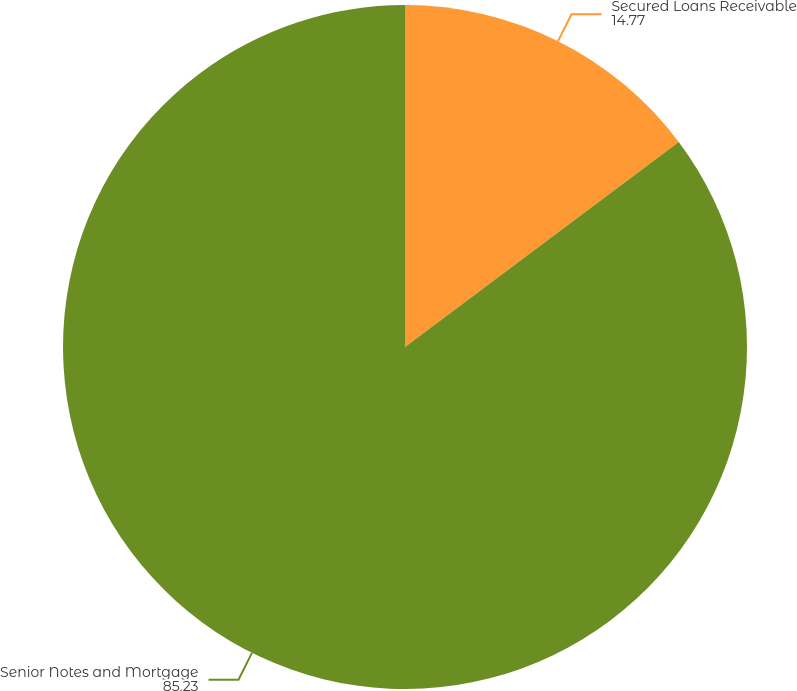Convert chart to OTSL. <chart><loc_0><loc_0><loc_500><loc_500><pie_chart><fcel>Secured Loans Receivable<fcel>Senior Notes and Mortgage<nl><fcel>14.77%<fcel>85.23%<nl></chart> 